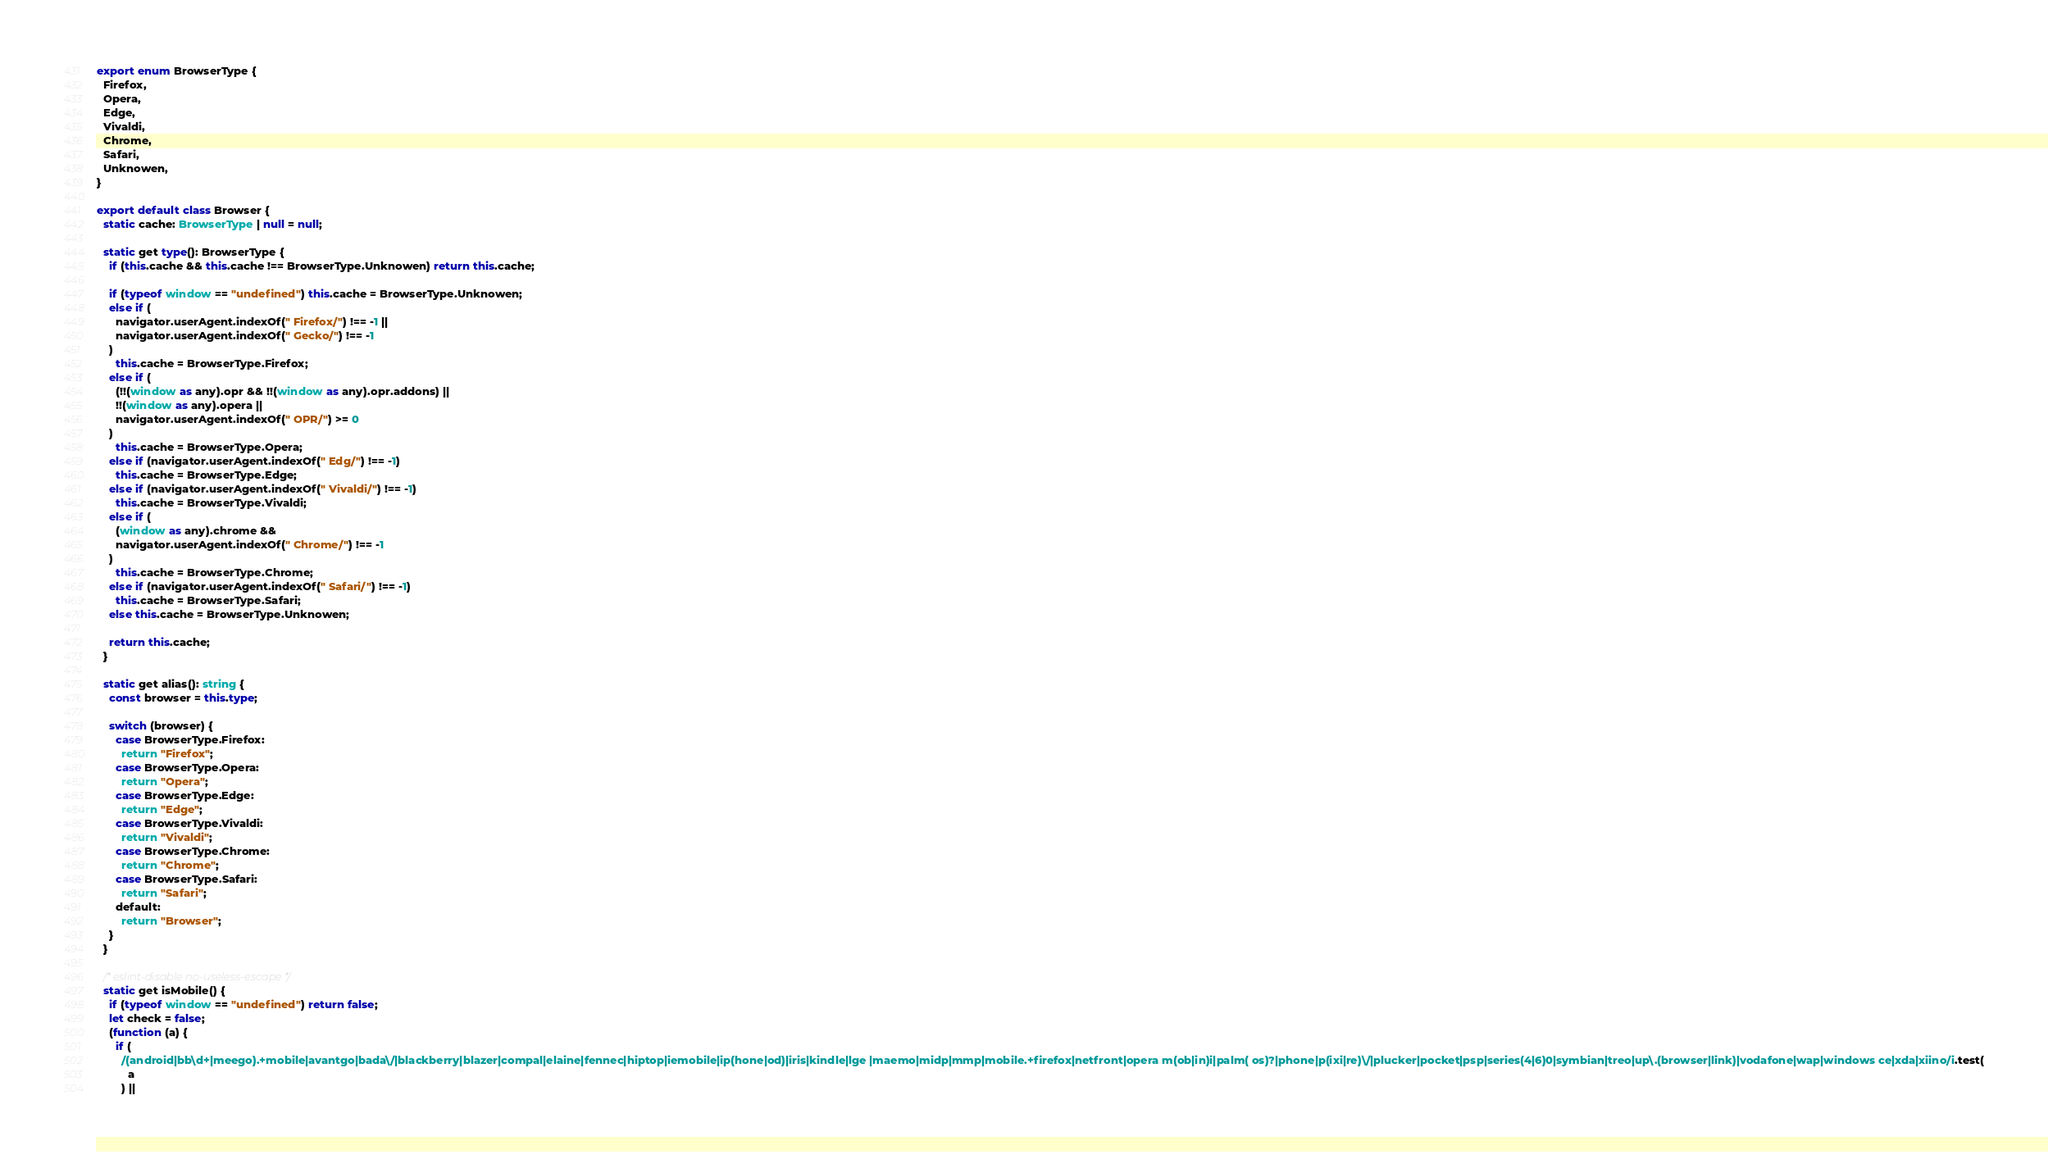<code> <loc_0><loc_0><loc_500><loc_500><_TypeScript_>export enum BrowserType {
  Firefox,
  Opera,
  Edge,
  Vivaldi,
  Chrome,
  Safari,
  Unknowen,
}

export default class Browser {
  static cache: BrowserType | null = null;

  static get type(): BrowserType {
    if (this.cache && this.cache !== BrowserType.Unknowen) return this.cache;

    if (typeof window == "undefined") this.cache = BrowserType.Unknowen;
    else if (
      navigator.userAgent.indexOf(" Firefox/") !== -1 ||
      navigator.userAgent.indexOf(" Gecko/") !== -1
    )
      this.cache = BrowserType.Firefox;
    else if (
      (!!(window as any).opr && !!(window as any).opr.addons) ||
      !!(window as any).opera ||
      navigator.userAgent.indexOf(" OPR/") >= 0
    )
      this.cache = BrowserType.Opera;
    else if (navigator.userAgent.indexOf(" Edg/") !== -1)
      this.cache = BrowserType.Edge;
    else if (navigator.userAgent.indexOf(" Vivaldi/") !== -1)
      this.cache = BrowserType.Vivaldi;
    else if (
      (window as any).chrome &&
      navigator.userAgent.indexOf(" Chrome/") !== -1
    )
      this.cache = BrowserType.Chrome;
    else if (navigator.userAgent.indexOf(" Safari/") !== -1)
      this.cache = BrowserType.Safari;
    else this.cache = BrowserType.Unknowen;

    return this.cache;
  }

  static get alias(): string {
    const browser = this.type;

    switch (browser) {
      case BrowserType.Firefox:
        return "Firefox";
      case BrowserType.Opera:
        return "Opera";
      case BrowserType.Edge:
        return "Edge";
      case BrowserType.Vivaldi:
        return "Vivaldi";
      case BrowserType.Chrome:
        return "Chrome";
      case BrowserType.Safari:
        return "Safari";
      default:
        return "Browser";
    }
  }

  /* eslint-disable no-useless-escape */
  static get isMobile() {
    if (typeof window == "undefined") return false;
    let check = false;
    (function (a) {
      if (
        /(android|bb\d+|meego).+mobile|avantgo|bada\/|blackberry|blazer|compal|elaine|fennec|hiptop|iemobile|ip(hone|od)|iris|kindle|lge |maemo|midp|mmp|mobile.+firefox|netfront|opera m(ob|in)i|palm( os)?|phone|p(ixi|re)\/|plucker|pocket|psp|series(4|6)0|symbian|treo|up\.(browser|link)|vodafone|wap|windows ce|xda|xiino/i.test(
          a
        ) ||</code> 